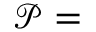Convert formula to latex. <formula><loc_0><loc_0><loc_500><loc_500>\mathcal { P } =</formula> 